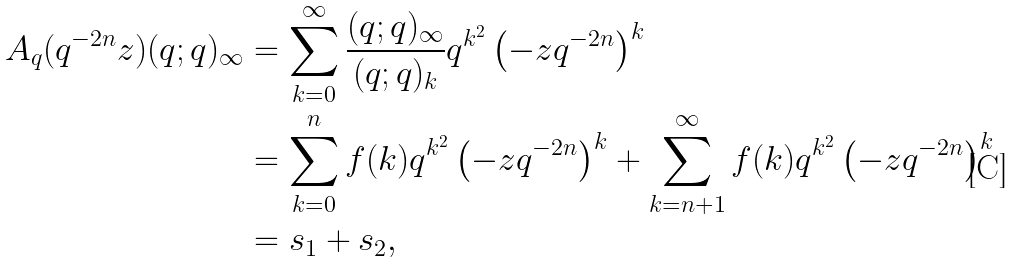Convert formula to latex. <formula><loc_0><loc_0><loc_500><loc_500>A _ { q } ( q ^ { - 2 n } z ) ( q ; q ) _ { \infty } & = \sum _ { k = 0 } ^ { \infty } \frac { ( q ; q ) _ { \infty } } { ( q ; q ) _ { k } } q ^ { k ^ { 2 } } \left ( - z q ^ { - 2 n } \right ) ^ { k } \\ & = \sum _ { k = 0 } ^ { n } f ( k ) q ^ { k ^ { 2 } } \left ( - z q ^ { - 2 n } \right ) ^ { k } + \sum _ { k = n + 1 } ^ { \infty } f ( k ) q ^ { k ^ { 2 } } \left ( - z q ^ { - 2 n } \right ) ^ { k } \\ & = s _ { 1 } + s _ { 2 } ,</formula> 